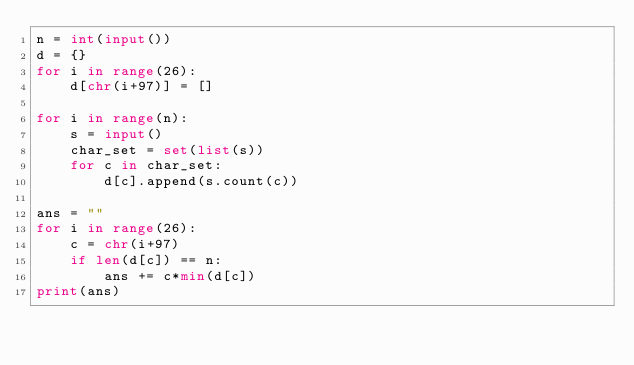<code> <loc_0><loc_0><loc_500><loc_500><_Python_>n = int(input())
d = {}
for i in range(26):
    d[chr(i+97)] = []

for i in range(n):
    s = input()
    char_set = set(list(s))
    for c in char_set:
        d[c].append(s.count(c))

ans = ""
for i in range(26):
    c = chr(i+97)
    if len(d[c]) == n:
        ans += c*min(d[c])
print(ans)</code> 